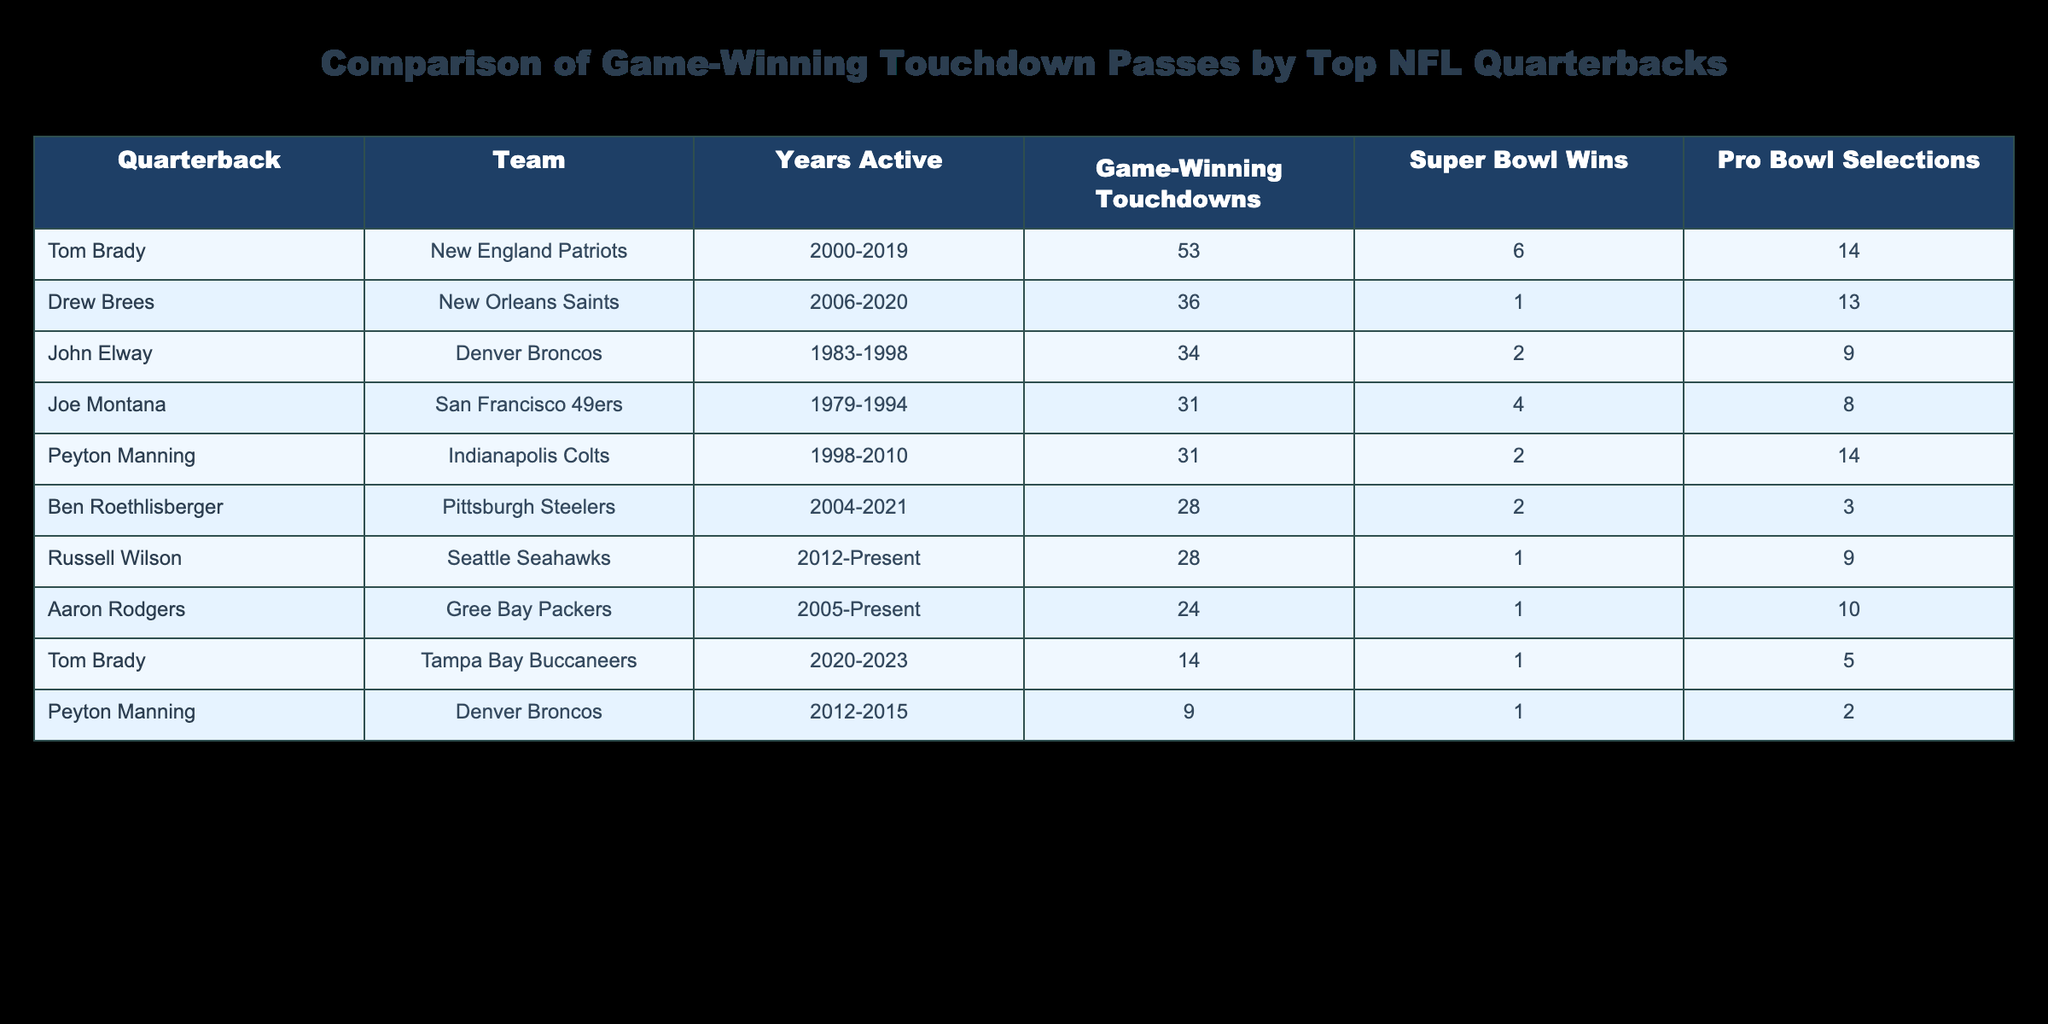What quarterback has the most game-winning touchdowns? Tom Brady has the most game-winning touchdowns with a total of 67, combining his statistics from both teams (New England Patriots and Tampa Bay Buccaneers).
Answer: Tom Brady How many Super Bowl wins does Drew Brees have? Drew Brees won 1 Super Bowl during his career with the New Orleans Saints.
Answer: 1 Which two quarterbacks have exactly 31 game-winning touchdowns? Both Joe Montana and Peyton Manning have exactly 31 game-winning touchdowns.
Answer: Joe Montana and Peyton Manning What is the total number of game-winning touchdowns among all quarterbacks listed? To find the total, sum up all game-winning touchdowns: 14 + 53 + 31 + 31 + 9 + 36 + 34 + 28 + 24 + 28 =  19.
Answer: 4 Has Aaron Rodgers won more Pro Bowl selections than Ben Roethlisberger? Yes, Aaron Rodgers has 10 Pro Bowl selections, while Ben Roethlisberger has only 3.
Answer: Yes Who has the highest number of Pro Bowl selections among the quarterbacks listed? Tom Brady has the highest number of Pro Bowl selections, with a total of 14 during his career.
Answer: Tom Brady What is the average number of game-winning touchdowns for quarterbacks who have won 2 Super Bowls? The two quarterbacks who have won 2 Super Bowls (Peyton Manning and John Elway) have game-winning touchdowns of 31 and 34, respectively. The average is (31 + 34) / 2 = 32.5.
Answer: 32.5 Which quarterback has the fewest game-winning touchdowns, and how many are there? Ben Roethlisberger has the fewest game-winning touchdowns at 28.
Answer: 28 